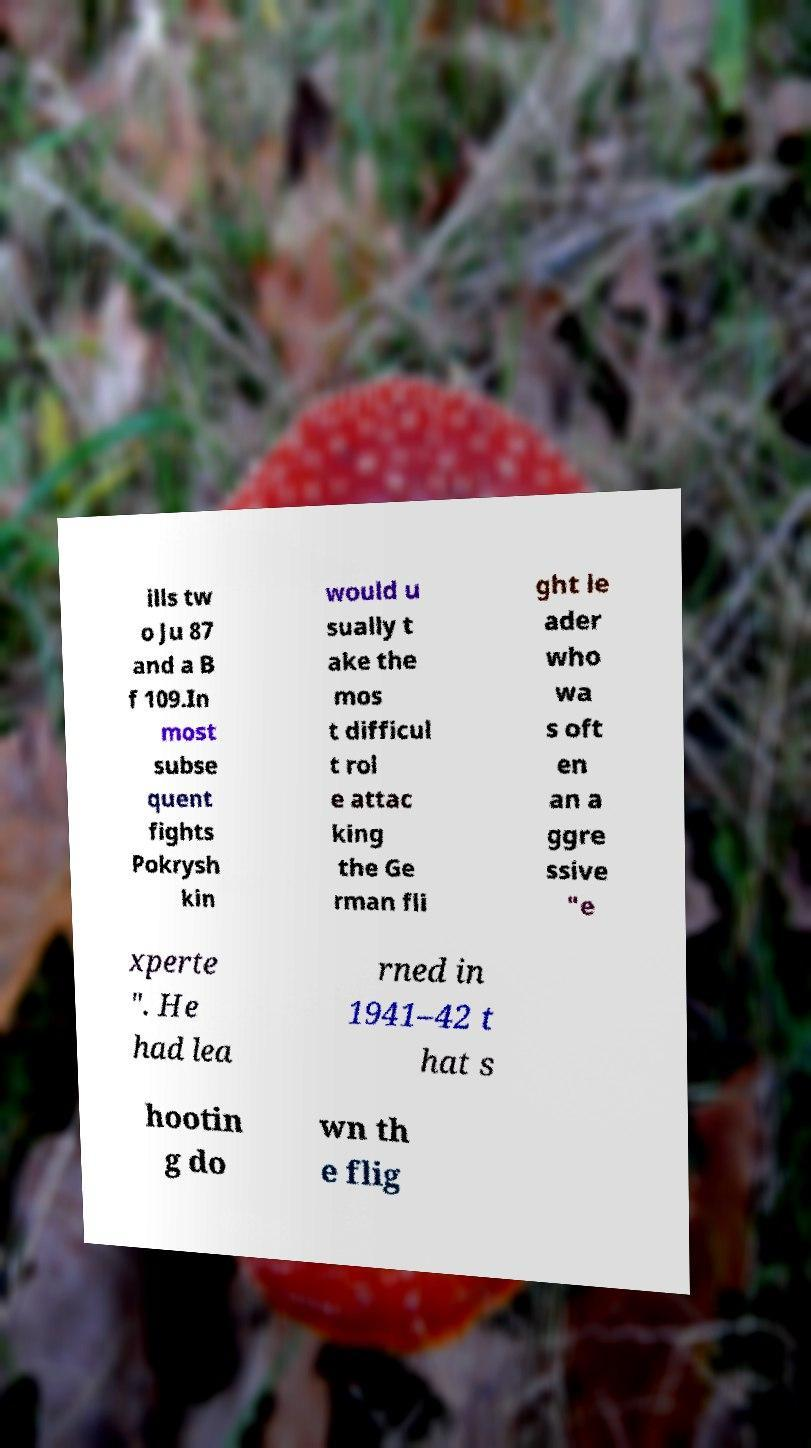Could you extract and type out the text from this image? ills tw o Ju 87 and a B f 109.In most subse quent fights Pokrysh kin would u sually t ake the mos t difficul t rol e attac king the Ge rman fli ght le ader who wa s oft en an a ggre ssive "e xperte ". He had lea rned in 1941–42 t hat s hootin g do wn th e flig 